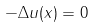Convert formula to latex. <formula><loc_0><loc_0><loc_500><loc_500>- \Delta u ( x ) = 0</formula> 